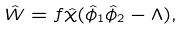<formula> <loc_0><loc_0><loc_500><loc_500>\hat { W } = f \hat { \chi } ( \hat { \phi } _ { 1 } \hat { \phi } _ { 2 } - \Lambda ) ,</formula> 